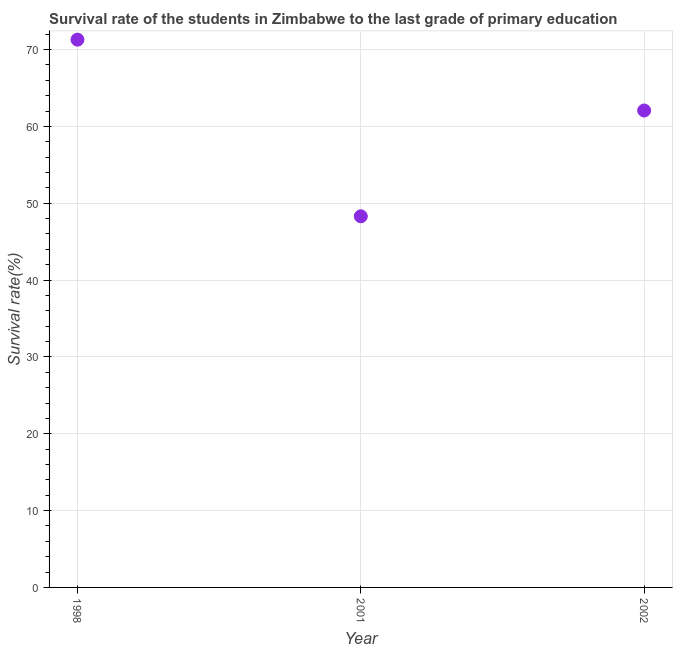What is the survival rate in primary education in 2001?
Keep it short and to the point. 48.3. Across all years, what is the maximum survival rate in primary education?
Ensure brevity in your answer.  71.29. Across all years, what is the minimum survival rate in primary education?
Your answer should be compact. 48.3. In which year was the survival rate in primary education maximum?
Your response must be concise. 1998. In which year was the survival rate in primary education minimum?
Provide a short and direct response. 2001. What is the sum of the survival rate in primary education?
Ensure brevity in your answer.  181.67. What is the difference between the survival rate in primary education in 1998 and 2001?
Your answer should be compact. 22.99. What is the average survival rate in primary education per year?
Ensure brevity in your answer.  60.56. What is the median survival rate in primary education?
Offer a terse response. 62.07. In how many years, is the survival rate in primary education greater than 26 %?
Offer a terse response. 3. Do a majority of the years between 2001 and 1998 (inclusive) have survival rate in primary education greater than 38 %?
Your answer should be compact. No. What is the ratio of the survival rate in primary education in 2001 to that in 2002?
Offer a terse response. 0.78. Is the survival rate in primary education in 2001 less than that in 2002?
Make the answer very short. Yes. Is the difference between the survival rate in primary education in 1998 and 2002 greater than the difference between any two years?
Offer a terse response. No. What is the difference between the highest and the second highest survival rate in primary education?
Your response must be concise. 9.22. What is the difference between the highest and the lowest survival rate in primary education?
Offer a terse response. 22.99. Does the survival rate in primary education monotonically increase over the years?
Provide a succinct answer. No. Are the values on the major ticks of Y-axis written in scientific E-notation?
Give a very brief answer. No. Does the graph contain grids?
Your response must be concise. Yes. What is the title of the graph?
Ensure brevity in your answer.  Survival rate of the students in Zimbabwe to the last grade of primary education. What is the label or title of the Y-axis?
Keep it short and to the point. Survival rate(%). What is the Survival rate(%) in 1998?
Your response must be concise. 71.29. What is the Survival rate(%) in 2001?
Provide a short and direct response. 48.3. What is the Survival rate(%) in 2002?
Your answer should be very brief. 62.07. What is the difference between the Survival rate(%) in 1998 and 2001?
Offer a terse response. 22.99. What is the difference between the Survival rate(%) in 1998 and 2002?
Offer a very short reply. 9.22. What is the difference between the Survival rate(%) in 2001 and 2002?
Your response must be concise. -13.77. What is the ratio of the Survival rate(%) in 1998 to that in 2001?
Ensure brevity in your answer.  1.48. What is the ratio of the Survival rate(%) in 1998 to that in 2002?
Ensure brevity in your answer.  1.15. What is the ratio of the Survival rate(%) in 2001 to that in 2002?
Provide a short and direct response. 0.78. 